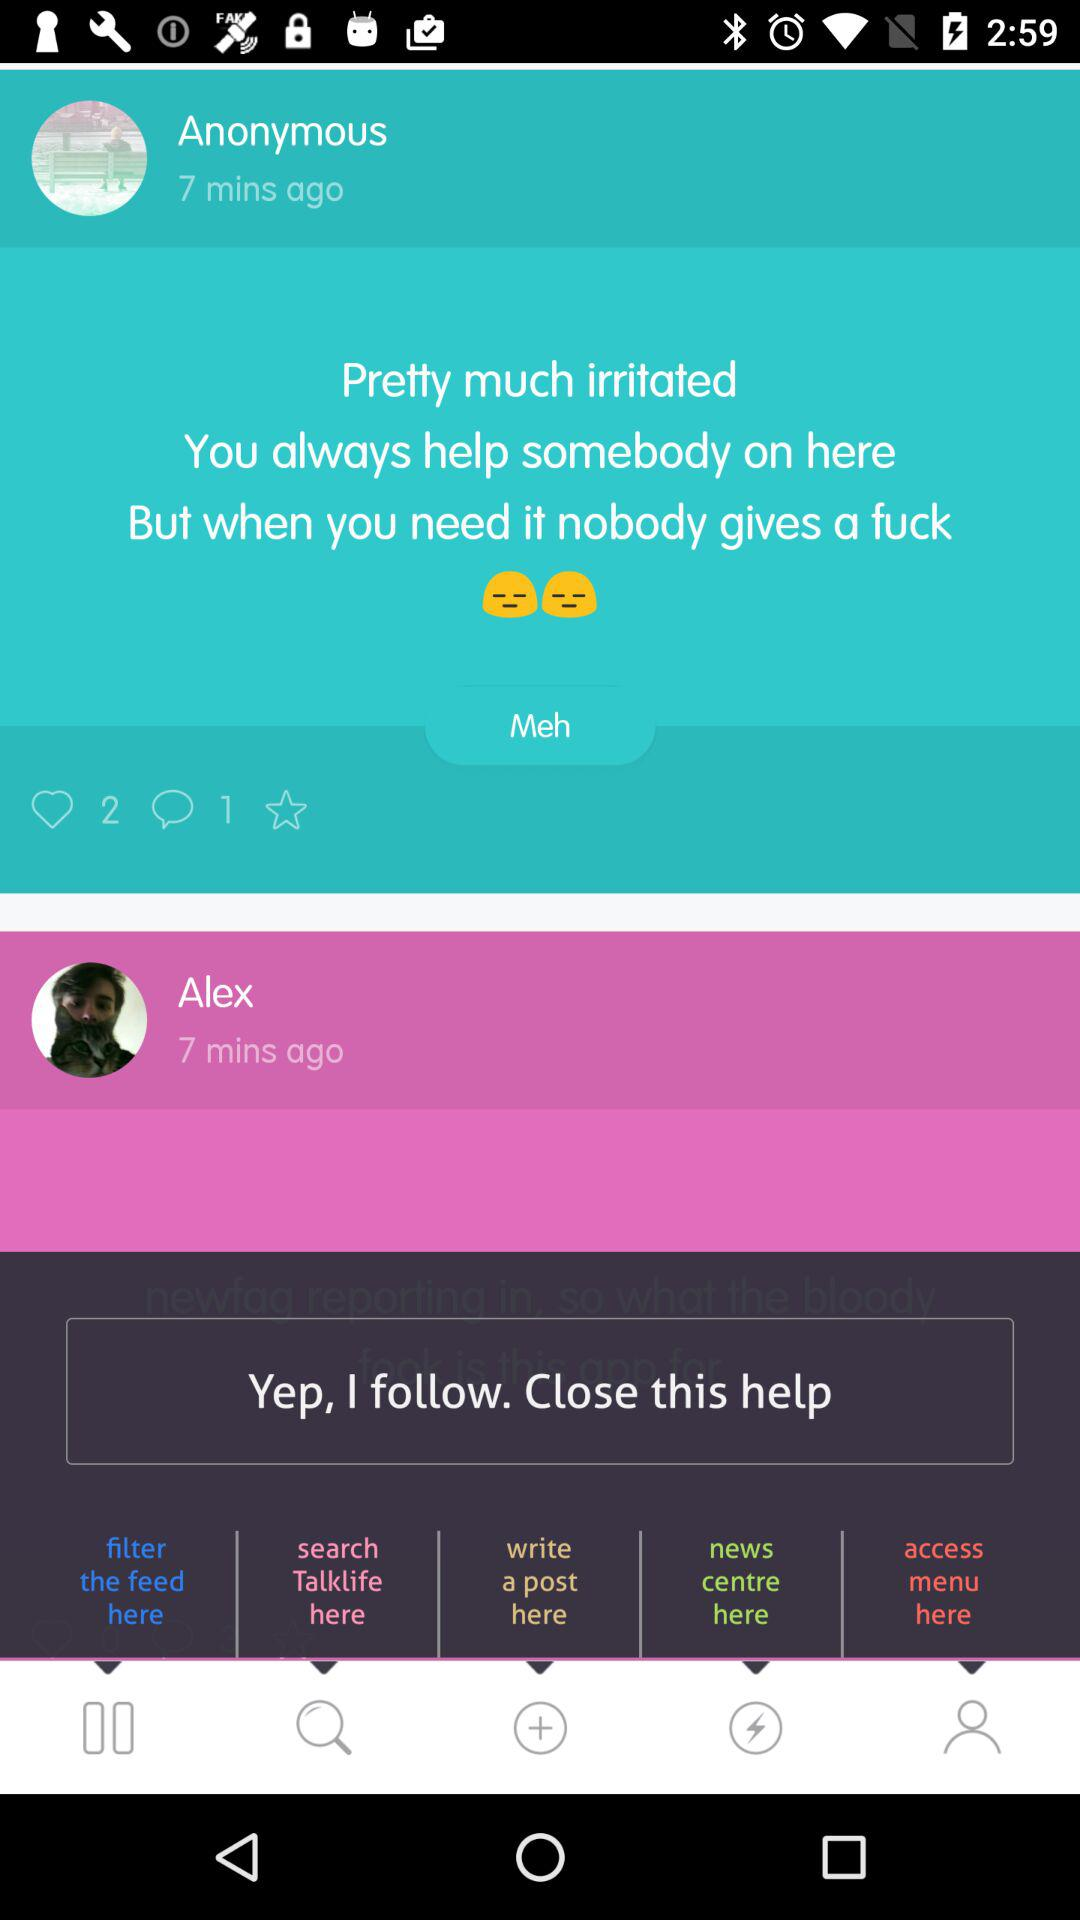On what day did Anonymous post?
When the provided information is insufficient, respond with <no answer>. <no answer> 